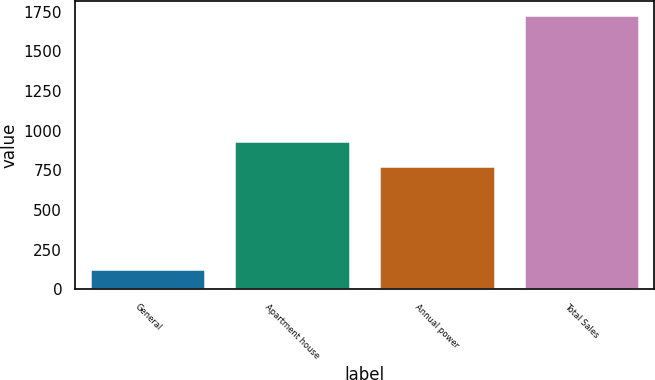Convert chart. <chart><loc_0><loc_0><loc_500><loc_500><bar_chart><fcel>General<fcel>Apartment house<fcel>Annual power<fcel>Total Sales<nl><fcel>129<fcel>937<fcel>777<fcel>1729<nl></chart> 